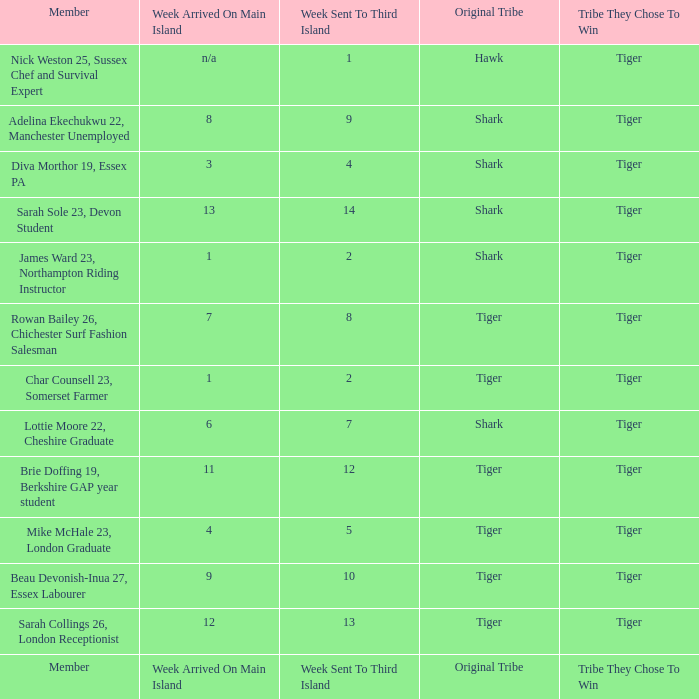How many members arrived on the main island in week 4? 1.0. 